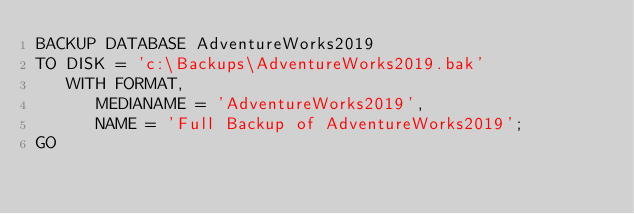<code> <loc_0><loc_0><loc_500><loc_500><_SQL_>BACKUP DATABASE AdventureWorks2019
TO DISK = 'c:\Backups\AdventureWorks2019.bak'
   WITH FORMAT,
      MEDIANAME = 'AdventureWorks2019',
      NAME = 'Full Backup of AdventureWorks2019';
GO</code> 